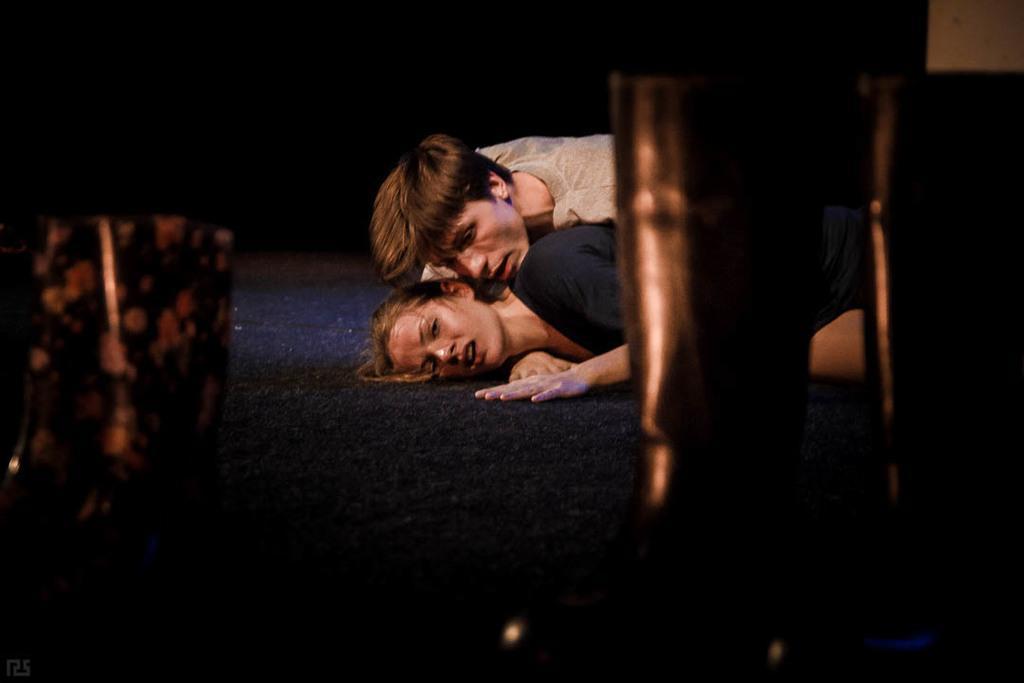In one or two sentences, can you explain what this image depicts? In this picture we can see a girl and a boy on each other lying on the flooring mat. 